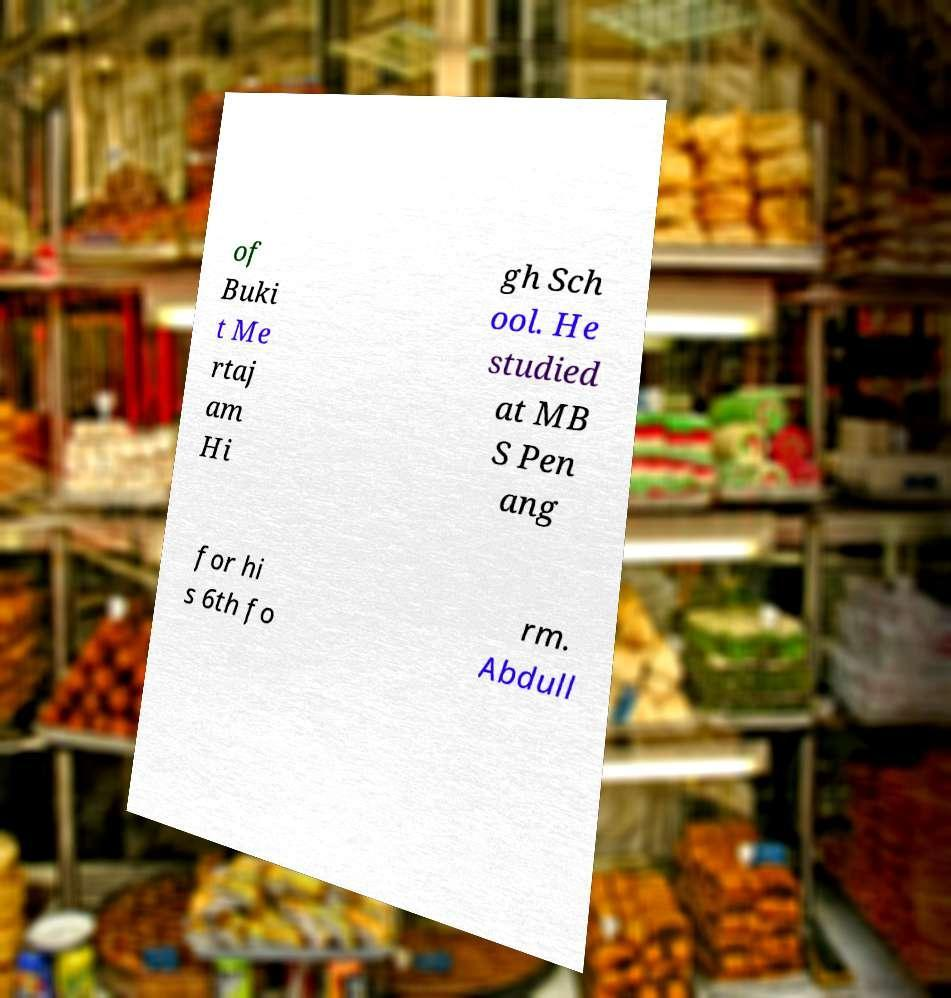Can you accurately transcribe the text from the provided image for me? of Buki t Me rtaj am Hi gh Sch ool. He studied at MB S Pen ang for hi s 6th fo rm. Abdull 